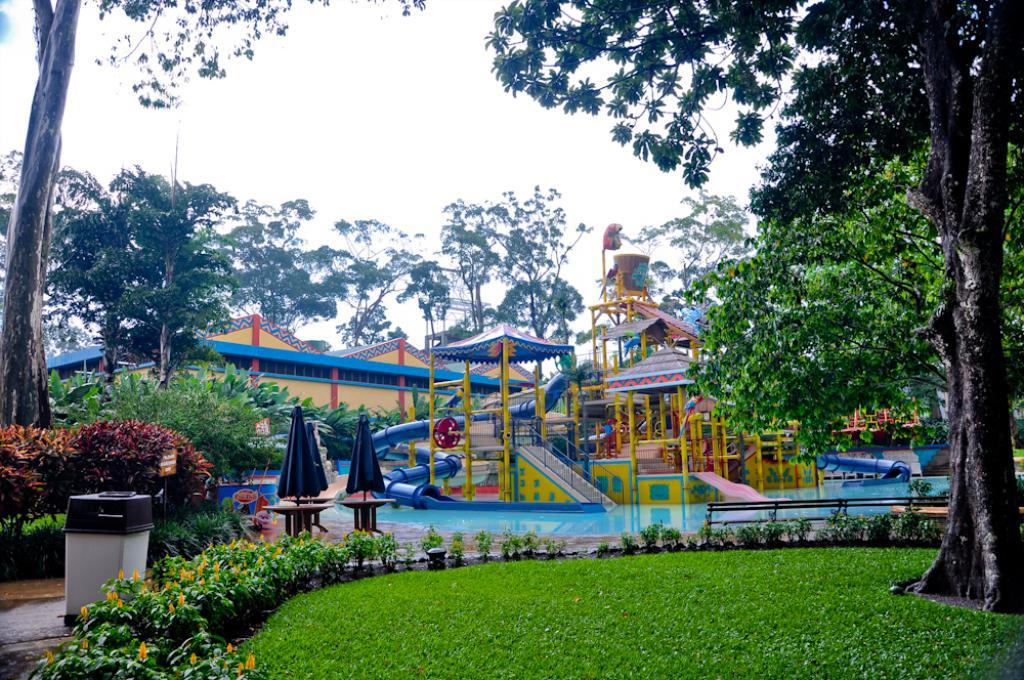What type of plants are present in the image? There are plants with yellow flowers in the image. Where is the dustbin located in the image? The dustbin is on the left side of the image. What can be seen in the background of the image? Watersides, trees, and the sky are visible in the background of the image. What is the topic of the discussion taking place in the image? There is no discussion taking place in the image; it is a still image of plants, a dustbin, and the background. 